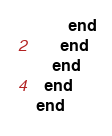Convert code to text. <code><loc_0><loc_0><loc_500><loc_500><_Ruby_>        end
      end
    end
  end
end
</code> 